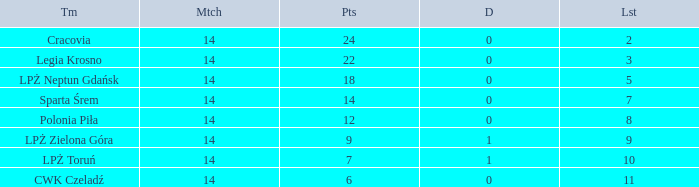What is the sum for the match with a draw less than 0? None. 